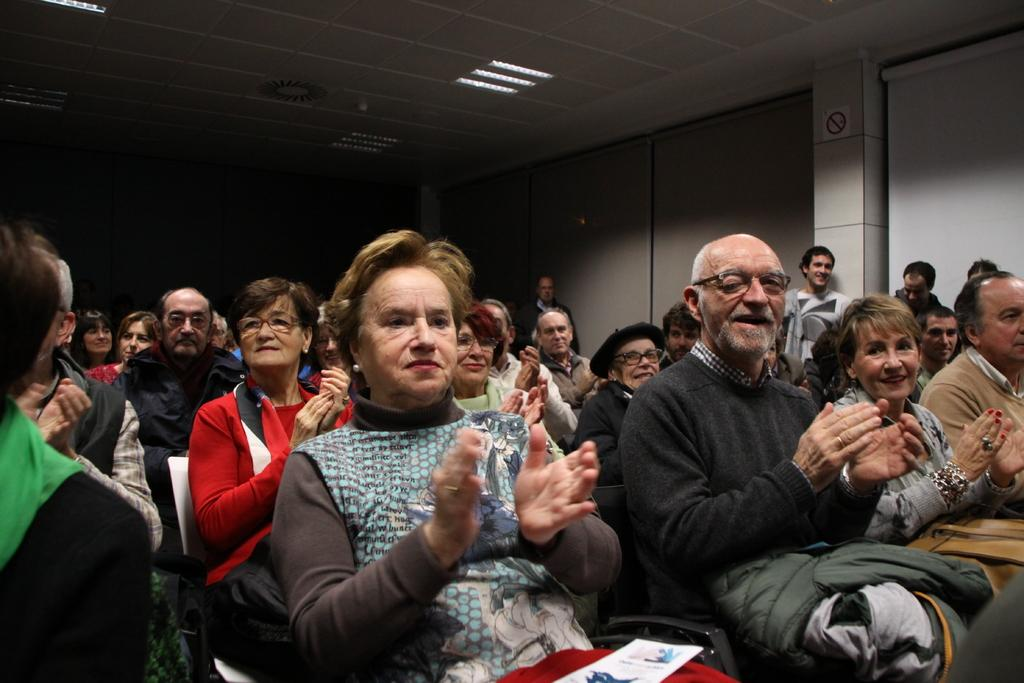How many people are in the image? There is a group of people in the image, but the exact number is not specified. What are the people in the image doing? The people are sitting and clapping their hands. What type of corn can be seen growing in the image? There is no corn present in the image. How many clouds are visible in the image? There is no mention of clouds in the image, so we cannot determine how many are visible. 